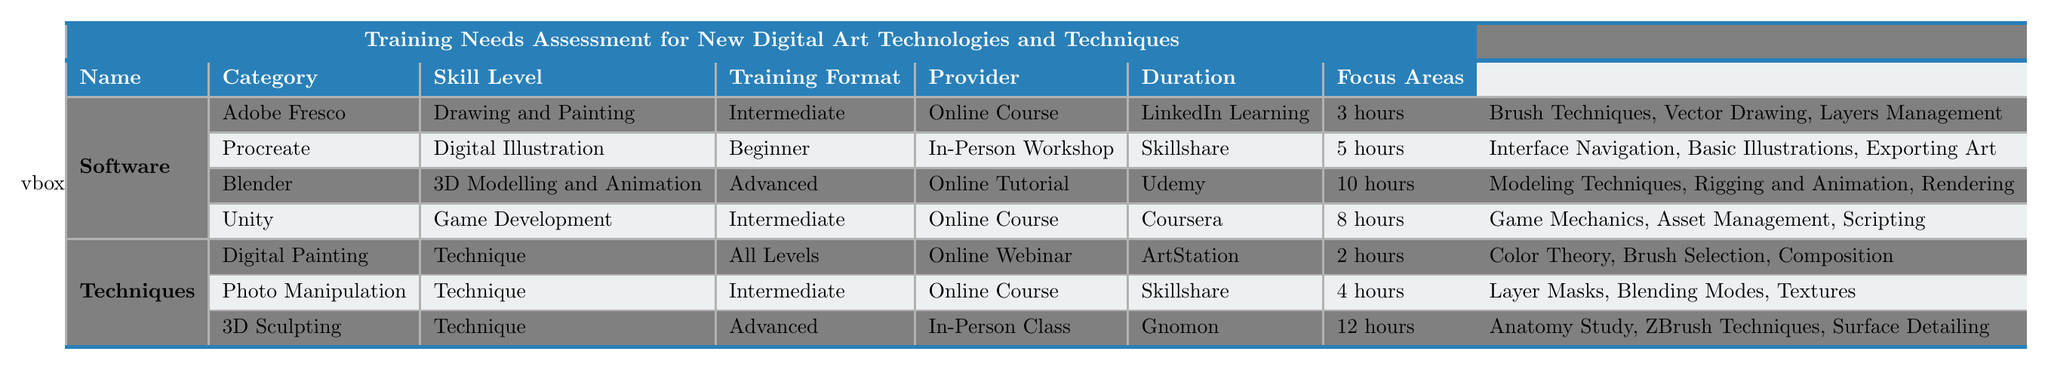What is the training format for Adobe Fresco? The training format for Adobe Fresco is specified in the table. It is listed under the "Training Format" column next to Adobe Fresco, which is "Online Course."
Answer: Online Course Which software has the longest training duration? The training durations are provided for each software. By comparing all durations, Blender has the longest duration at 10 hours.
Answer: Blender How many training methods are available for techniques? The table details three techniques, each having their own training methods specified. Therefore, there are three training methods available for techniques.
Answer: 3 Is Procreate categorized as Intermediate skill level? Looking at the "Skill Level" column for Procreate, it shows "Beginner," so it is not categorized as Intermediate.
Answer: No What are the focus areas of the Digital Painting technique? The focus areas for Digital Painting are listed in the table under "Focus Areas" corresponding to the Digital Painting entry, which includes "Color Theory, Brush Selection, Composition."
Answer: Color Theory, Brush Selection, Composition Which provider offers an in-person class for 3D Sculpting? The table indicates that Gnomon is the provider for the technique "3D Sculpting," and it is listed as an "In-Person Class."
Answer: Gnomon How many different skill levels are represented across both software and techniques? By examining all the skill levels in the table, they include: Beginner, Intermediate, Advanced, and All Levels. Counting these gives us four distinct skill levels.
Answer: 4 What is the average duration of training across all software? The durations for software are 3 hours (Adobe Fresco), 5 hours (Procreate), 10 hours (Blender), and 8 hours (Unity). Summing these gives 26 hours, and dividing by 4 (the number of software) results in 6.5 hours.
Answer: 6.5 hours Is "Adaptability to New Tools" considered a high importance criteria? In the table, the importance for "Adaptability to New Tools" is labeled as "Medium," hence it is not high importance.
Answer: No Which training format is the most common for techniques? The training formats for techniques include Online Webinar and Online Course. By frequency count, Online Course appears twice, while Online Webinar appears once. Thus, Online Course is the most common format for techniques.
Answer: Online Course 